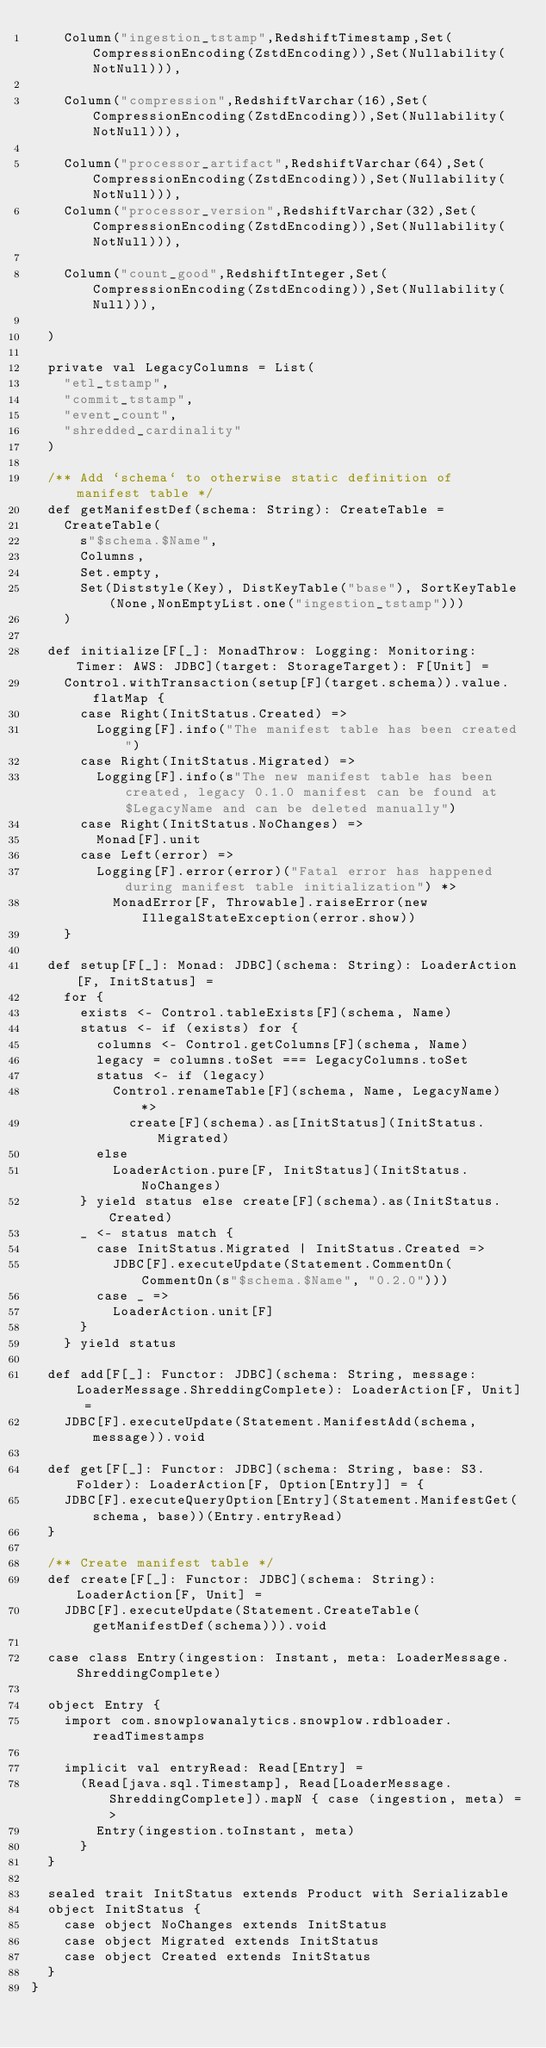Convert code to text. <code><loc_0><loc_0><loc_500><loc_500><_Scala_>    Column("ingestion_tstamp",RedshiftTimestamp,Set(CompressionEncoding(ZstdEncoding)),Set(Nullability(NotNull))),

    Column("compression",RedshiftVarchar(16),Set(CompressionEncoding(ZstdEncoding)),Set(Nullability(NotNull))),

    Column("processor_artifact",RedshiftVarchar(64),Set(CompressionEncoding(ZstdEncoding)),Set(Nullability(NotNull))),
    Column("processor_version",RedshiftVarchar(32),Set(CompressionEncoding(ZstdEncoding)),Set(Nullability(NotNull))),

    Column("count_good",RedshiftInteger,Set(CompressionEncoding(ZstdEncoding)),Set(Nullability(Null))),

  )

  private val LegacyColumns = List(
    "etl_tstamp",
    "commit_tstamp",
    "event_count",
    "shredded_cardinality"
  )

  /** Add `schema` to otherwise static definition of manifest table */
  def getManifestDef(schema: String): CreateTable =
    CreateTable(
      s"$schema.$Name",
      Columns,
      Set.empty,
      Set(Diststyle(Key), DistKeyTable("base"), SortKeyTable(None,NonEmptyList.one("ingestion_tstamp")))
    )

  def initialize[F[_]: MonadThrow: Logging: Monitoring: Timer: AWS: JDBC](target: StorageTarget): F[Unit] =
    Control.withTransaction(setup[F](target.schema)).value.flatMap {
      case Right(InitStatus.Created) =>
        Logging[F].info("The manifest table has been created")
      case Right(InitStatus.Migrated) =>
        Logging[F].info(s"The new manifest table has been created, legacy 0.1.0 manifest can be found at $LegacyName and can be deleted manually")
      case Right(InitStatus.NoChanges) =>
        Monad[F].unit
      case Left(error) =>
        Logging[F].error(error)("Fatal error has happened during manifest table initialization") *>
          MonadError[F, Throwable].raiseError(new IllegalStateException(error.show))
    }

  def setup[F[_]: Monad: JDBC](schema: String): LoaderAction[F, InitStatus] =
    for {
      exists <- Control.tableExists[F](schema, Name)
      status <- if (exists) for {
        columns <- Control.getColumns[F](schema, Name)
        legacy = columns.toSet === LegacyColumns.toSet
        status <- if (legacy)
          Control.renameTable[F](schema, Name, LegacyName) *>
            create[F](schema).as[InitStatus](InitStatus.Migrated)
        else
          LoaderAction.pure[F, InitStatus](InitStatus.NoChanges)
      } yield status else create[F](schema).as(InitStatus.Created)
      _ <- status match {
        case InitStatus.Migrated | InitStatus.Created =>
          JDBC[F].executeUpdate(Statement.CommentOn(CommentOn(s"$schema.$Name", "0.2.0")))
        case _ =>
          LoaderAction.unit[F]
      }
    } yield status

  def add[F[_]: Functor: JDBC](schema: String, message: LoaderMessage.ShreddingComplete): LoaderAction[F, Unit] =
    JDBC[F].executeUpdate(Statement.ManifestAdd(schema, message)).void

  def get[F[_]: Functor: JDBC](schema: String, base: S3.Folder): LoaderAction[F, Option[Entry]] = {
    JDBC[F].executeQueryOption[Entry](Statement.ManifestGet(schema, base))(Entry.entryRead)
  }

  /** Create manifest table */
  def create[F[_]: Functor: JDBC](schema: String): LoaderAction[F, Unit] =
    JDBC[F].executeUpdate(Statement.CreateTable(getManifestDef(schema))).void

  case class Entry(ingestion: Instant, meta: LoaderMessage.ShreddingComplete)

  object Entry {
    import com.snowplowanalytics.snowplow.rdbloader.readTimestamps

    implicit val entryRead: Read[Entry] =
      (Read[java.sql.Timestamp], Read[LoaderMessage.ShreddingComplete]).mapN { case (ingestion, meta) =>
        Entry(ingestion.toInstant, meta)
      }
  }

  sealed trait InitStatus extends Product with Serializable
  object InitStatus {
    case object NoChanges extends InitStatus
    case object Migrated extends InitStatus
    case object Created extends InitStatus
  }
}
</code> 